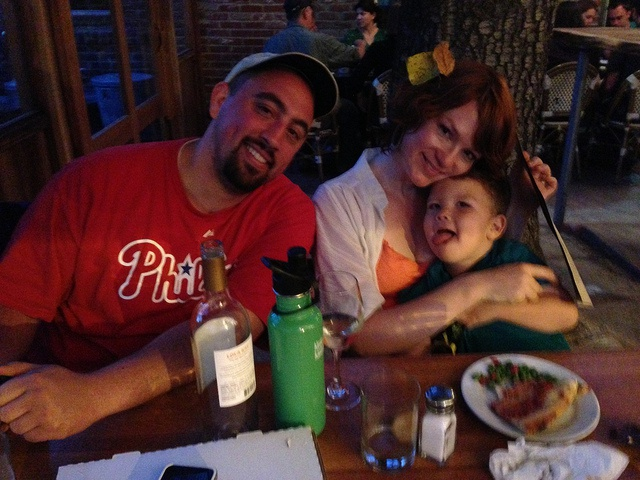Describe the objects in this image and their specific colors. I can see people in black, maroon, and brown tones, dining table in black, maroon, darkgray, and gray tones, people in black, maroon, brown, and darkgray tones, people in black, maroon, salmon, and brown tones, and bottle in black, maroon, tan, and lightgray tones in this image. 